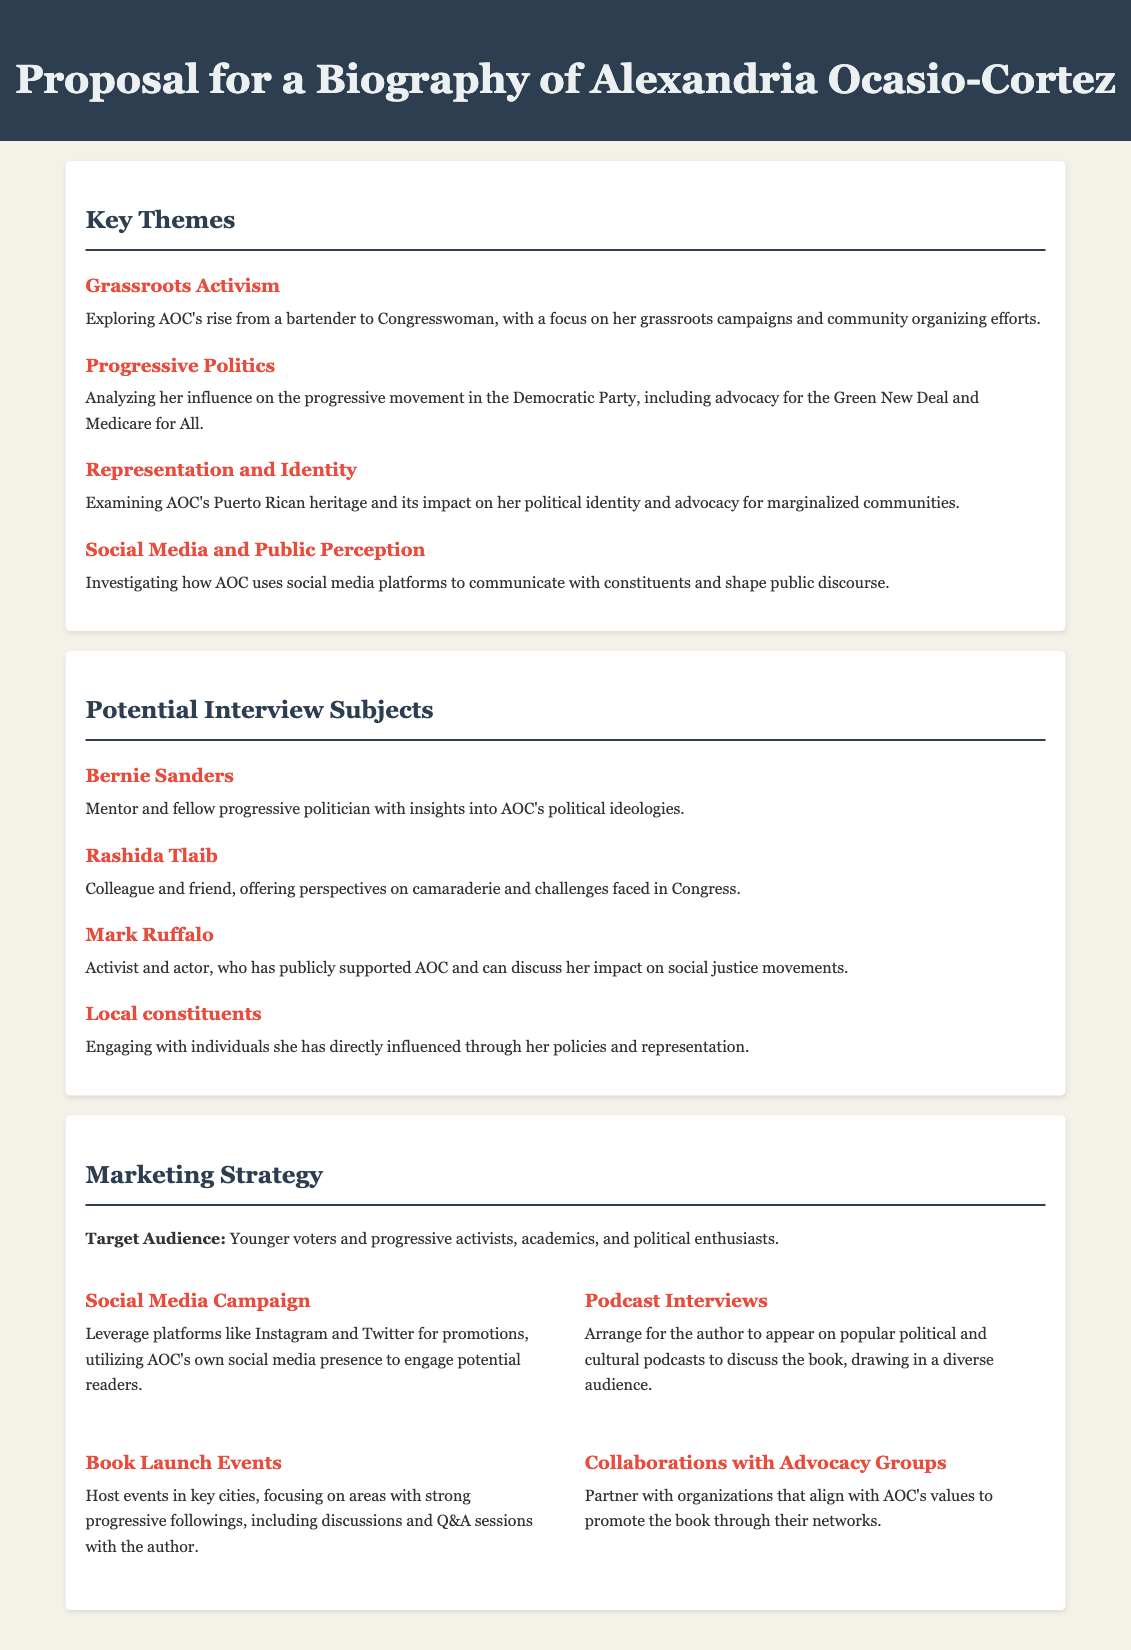What is the subject of the biography proposal? The document outlines a proposal for a biography of Alexandria Ocasio-Cortez.
Answer: Alexandria Ocasio-Cortez What theme addresses AOC's community involvement? The theme that focuses on her community involvement is titled "Grassroots Activism."
Answer: Grassroots Activism Which political figure is suggested as a potential interview subject? The document lists Bernie Sanders as one of the potential interview subjects.
Answer: Bernie Sanders What grassroots campaign aspect is highlighted in the key themes? The proposal highlights AOC's rise from a bartender to Congresswoman, focusing on grassroots campaigns.
Answer: Grassroots campaigns What marketing strategy involves using social media? The marketing strategy that involves social media is called "Social Media Campaign."
Answer: Social Media Campaign How many key themes are outlined in this proposal? There are four key themes outlined in the proposal related to AOC's biography.
Answer: Four Which social media platforms are mentioned for the marketing campaign? The marketing campaign mentions using Instagram and Twitter.
Answer: Instagram and Twitter What type of audience is targeted in the marketing strategy? The target audience includes younger voters and progressive activists.
Answer: Younger voters and progressive activists 